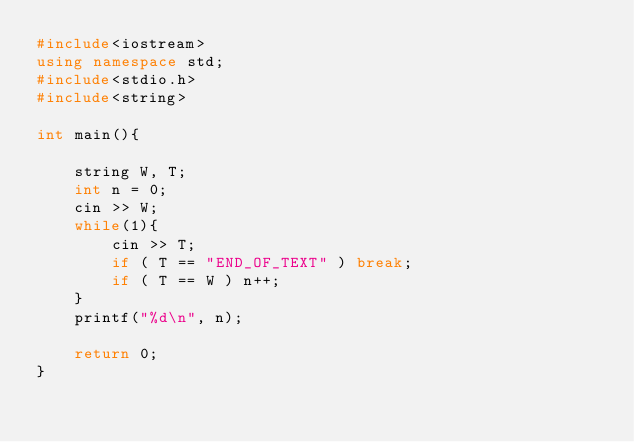Convert code to text. <code><loc_0><loc_0><loc_500><loc_500><_C++_>#include<iostream>
using namespace std;
#include<stdio.h>
#include<string>

int main(){
    
    string W, T;
    int n = 0;
    cin >> W;
    while(1){
        cin >> T;
        if ( T == "END_OF_TEXT" ) break;
        if ( T == W ) n++;
    }
    printf("%d\n", n);
    
    return 0;
}
</code> 